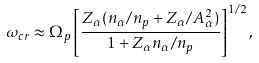Convert formula to latex. <formula><loc_0><loc_0><loc_500><loc_500>\omega _ { c r } \approx \Omega _ { p } \left [ \frac { Z _ { \alpha } ( n _ { \alpha } / n _ { p } + Z _ { \alpha } / A _ { \alpha } ^ { 2 } ) } { 1 + Z _ { \alpha } n _ { \alpha } / n _ { p } } \right ] ^ { 1 / 2 } ,</formula> 